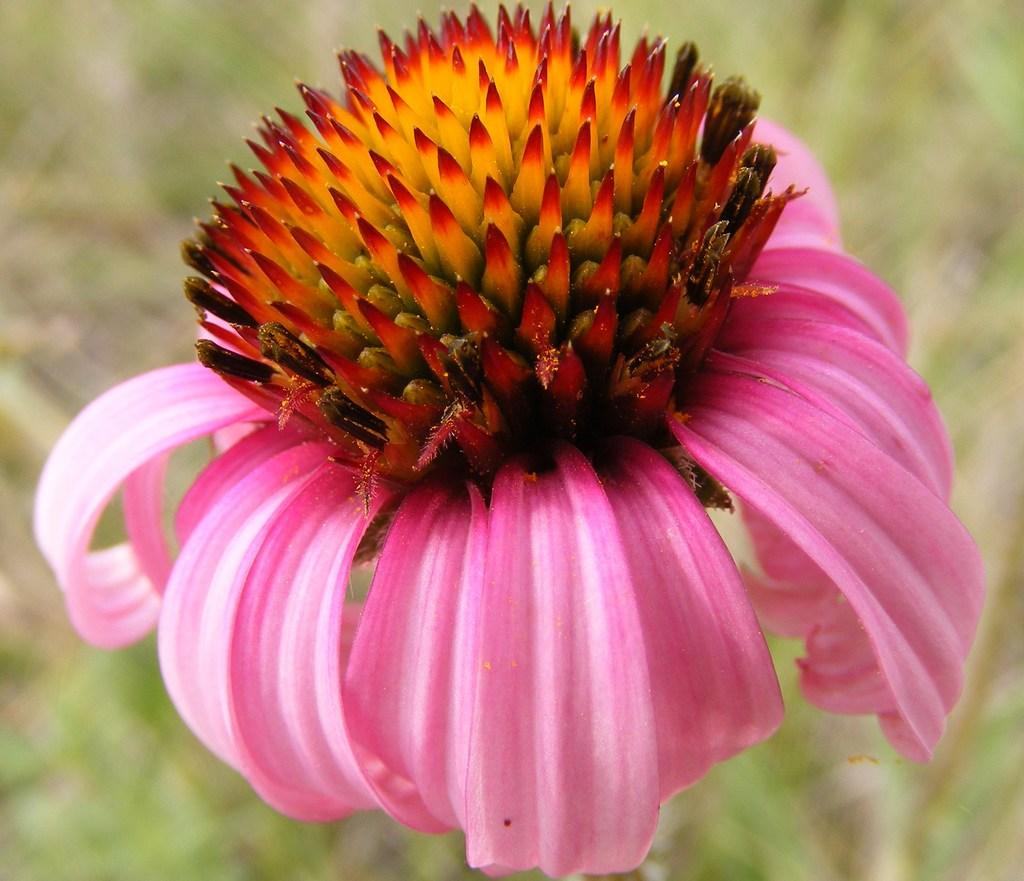What is present on the plant in the image? There is a flower on the plant in the image. What colors can be seen on the flower? The flower has pink, red, and yellow colors. Can you describe the background of the image? The background of the image is blurry. How does the flower increase in size in the image? The flower does not increase in size in the image; it is a static representation of the flower. 